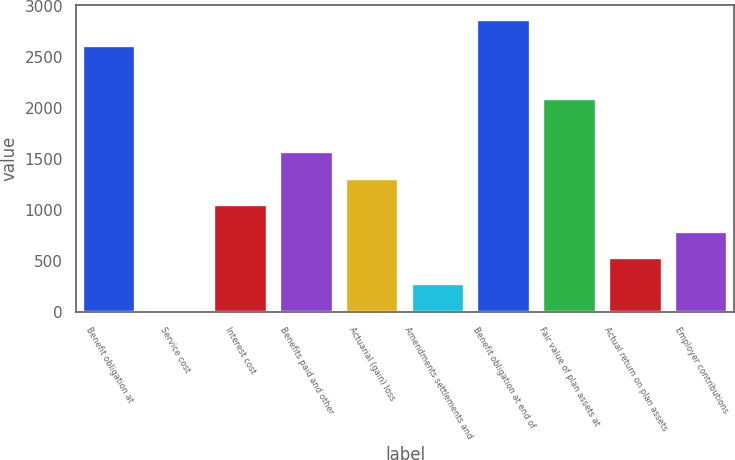Convert chart to OTSL. <chart><loc_0><loc_0><loc_500><loc_500><bar_chart><fcel>Benefit obligation at<fcel>Service cost<fcel>Interest cost<fcel>Benefits paid and other<fcel>Actuarial (gain) loss<fcel>Amendments settlements and<fcel>Benefit obligation at end of<fcel>Fair value of plan assets at<fcel>Actual return on plan assets<fcel>Employer contributions<nl><fcel>2603.9<fcel>9.6<fcel>1047.32<fcel>1566.18<fcel>1306.75<fcel>269.03<fcel>2863.33<fcel>2085.04<fcel>528.46<fcel>787.89<nl></chart> 